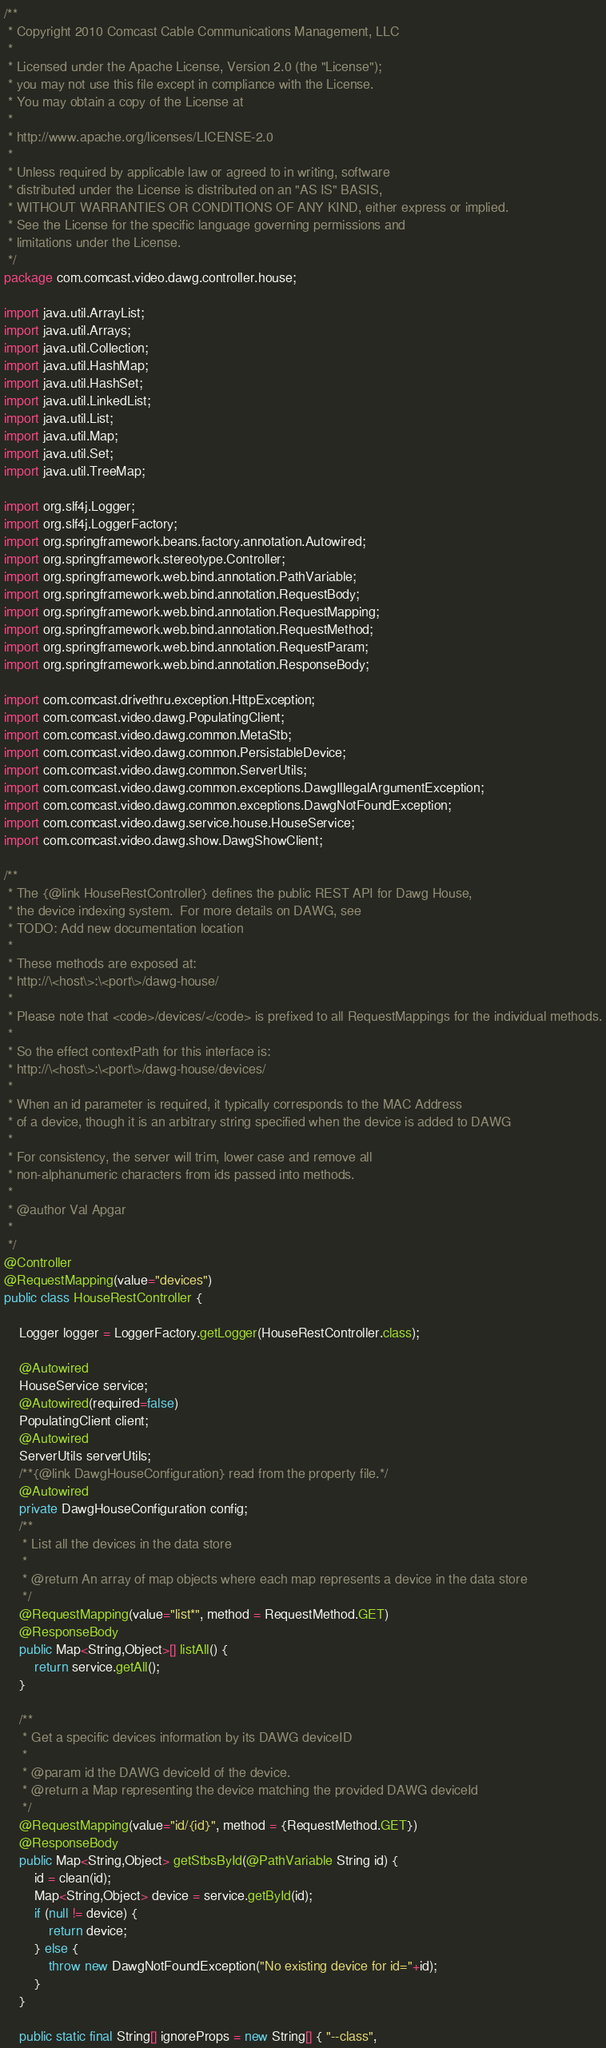Convert code to text. <code><loc_0><loc_0><loc_500><loc_500><_Java_>/**
 * Copyright 2010 Comcast Cable Communications Management, LLC
 *
 * Licensed under the Apache License, Version 2.0 (the "License");
 * you may not use this file except in compliance with the License.
 * You may obtain a copy of the License at
 *
 * http://www.apache.org/licenses/LICENSE-2.0
 *
 * Unless required by applicable law or agreed to in writing, software
 * distributed under the License is distributed on an "AS IS" BASIS,
 * WITHOUT WARRANTIES OR CONDITIONS OF ANY KIND, either express or implied.
 * See the License for the specific language governing permissions and
 * limitations under the License.
 */
package com.comcast.video.dawg.controller.house;

import java.util.ArrayList;
import java.util.Arrays;
import java.util.Collection;
import java.util.HashMap;
import java.util.HashSet;
import java.util.LinkedList;
import java.util.List;
import java.util.Map;
import java.util.Set;
import java.util.TreeMap;

import org.slf4j.Logger;
import org.slf4j.LoggerFactory;
import org.springframework.beans.factory.annotation.Autowired;
import org.springframework.stereotype.Controller;
import org.springframework.web.bind.annotation.PathVariable;
import org.springframework.web.bind.annotation.RequestBody;
import org.springframework.web.bind.annotation.RequestMapping;
import org.springframework.web.bind.annotation.RequestMethod;
import org.springframework.web.bind.annotation.RequestParam;
import org.springframework.web.bind.annotation.ResponseBody;

import com.comcast.drivethru.exception.HttpException;
import com.comcast.video.dawg.PopulatingClient;
import com.comcast.video.dawg.common.MetaStb;
import com.comcast.video.dawg.common.PersistableDevice;
import com.comcast.video.dawg.common.ServerUtils;
import com.comcast.video.dawg.common.exceptions.DawgIllegalArgumentException;
import com.comcast.video.dawg.common.exceptions.DawgNotFoundException;
import com.comcast.video.dawg.service.house.HouseService;
import com.comcast.video.dawg.show.DawgShowClient;

/**
 * The {@link HouseRestController} defines the public REST API for Dawg House,
 * the device indexing system.  For more details on DAWG, see
 * TODO: Add new documentation location
 *
 * These methods are exposed at:
 * http://\<host\>:\<port\>/dawg-house/
 *
 * Please note that <code>/devices/</code> is prefixed to all RequestMappings for the individual methods.
 *
 * So the effect contextPath for this interface is:
 * http://\<host\>:\<port\>/dawg-house/devices/
 *
 * When an id parameter is required, it typically corresponds to the MAC Address
 * of a device, though it is an arbitrary string specified when the device is added to DAWG
 *
 * For consistency, the server will trim, lower case and remove all
 * non-alphanumeric characters from ids passed into methods.
 *
 * @author Val Apgar
 *
 */
@Controller
@RequestMapping(value="devices")
public class HouseRestController {

    Logger logger = LoggerFactory.getLogger(HouseRestController.class);

    @Autowired
    HouseService service;
    @Autowired(required=false)
    PopulatingClient client;
    @Autowired
    ServerUtils serverUtils;
    /**{@link DawgHouseConfiguration} read from the property file.*/
    @Autowired
    private DawgHouseConfiguration config;
    /**
     * List all the devices in the data store
     *
     * @return An array of map objects where each map represents a device in the data store
     */
    @RequestMapping(value="list*", method = RequestMethod.GET)
    @ResponseBody
    public Map<String,Object>[] listAll() {
        return service.getAll();
    }

    /**
     * Get a specific devices information by its DAWG deviceID
     *
     * @param id the DAWG deviceId of the device.
     * @return a Map representing the device matching the provided DAWG deviceId
     */
    @RequestMapping(value="id/{id}", method = {RequestMethod.GET})
    @ResponseBody
    public Map<String,Object> getStbsById(@PathVariable String id) {
        id = clean(id);
        Map<String,Object> device = service.getById(id);
        if (null != device) {
            return device;
        } else {
            throw new DawgNotFoundException("No existing device for id="+id);
        }
    }

    public static final String[] ignoreProps = new String[] { "--class",</code> 